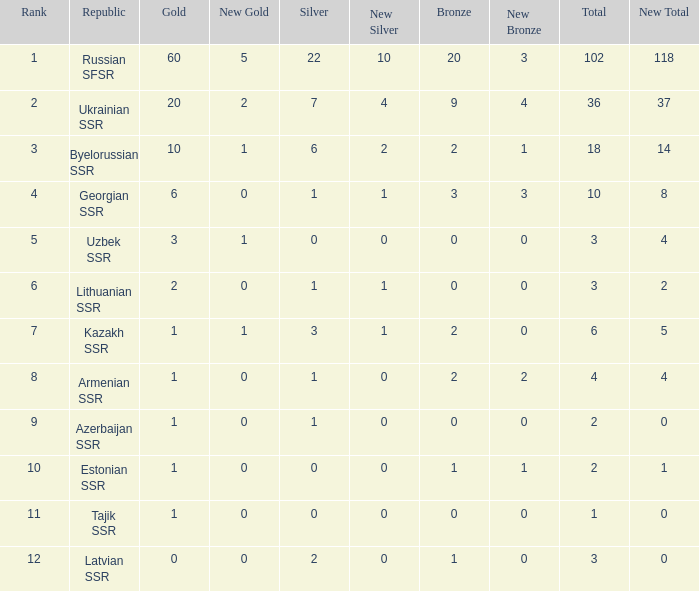What is the total number of bronzes associated with 1 silver, ranks under 6 and under 6 golds? None. 